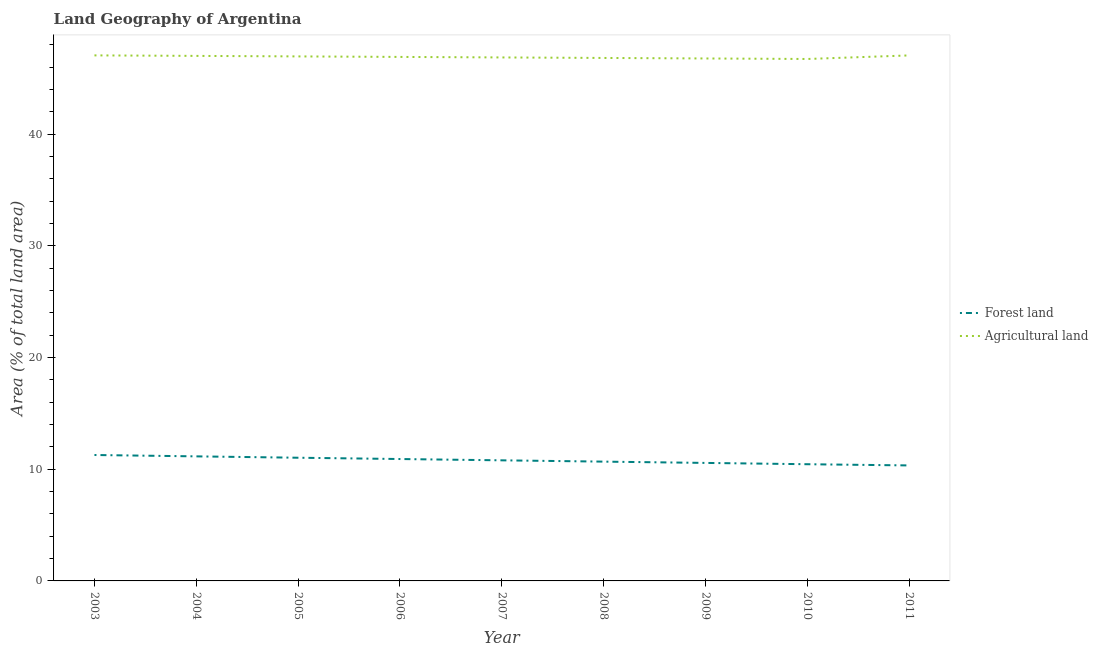Does the line corresponding to percentage of land area under forests intersect with the line corresponding to percentage of land area under agriculture?
Provide a short and direct response. No. Is the number of lines equal to the number of legend labels?
Offer a terse response. Yes. What is the percentage of land area under forests in 2004?
Ensure brevity in your answer.  11.15. Across all years, what is the maximum percentage of land area under agriculture?
Offer a terse response. 47.06. Across all years, what is the minimum percentage of land area under agriculture?
Ensure brevity in your answer.  46.73. What is the total percentage of land area under agriculture in the graph?
Make the answer very short. 422.21. What is the difference between the percentage of land area under forests in 2003 and that in 2010?
Your answer should be compact. 0.83. What is the difference between the percentage of land area under forests in 2008 and the percentage of land area under agriculture in 2010?
Make the answer very short. -36.05. What is the average percentage of land area under agriculture per year?
Provide a short and direct response. 46.91. In the year 2007, what is the difference between the percentage of land area under agriculture and percentage of land area under forests?
Ensure brevity in your answer.  36.07. What is the ratio of the percentage of land area under forests in 2004 to that in 2009?
Offer a terse response. 1.06. Is the percentage of land area under forests in 2006 less than that in 2011?
Ensure brevity in your answer.  No. What is the difference between the highest and the second highest percentage of land area under forests?
Offer a terse response. 0.12. What is the difference between the highest and the lowest percentage of land area under agriculture?
Give a very brief answer. 0.32. In how many years, is the percentage of land area under forests greater than the average percentage of land area under forests taken over all years?
Provide a short and direct response. 4. Is the percentage of land area under forests strictly greater than the percentage of land area under agriculture over the years?
Your answer should be very brief. No. Does the graph contain grids?
Make the answer very short. No. How many legend labels are there?
Provide a succinct answer. 2. What is the title of the graph?
Your response must be concise. Land Geography of Argentina. What is the label or title of the X-axis?
Provide a succinct answer. Year. What is the label or title of the Y-axis?
Give a very brief answer. Area (% of total land area). What is the Area (% of total land area) in Forest land in 2003?
Give a very brief answer. 11.27. What is the Area (% of total land area) of Agricultural land in 2003?
Offer a very short reply. 47.06. What is the Area (% of total land area) of Forest land in 2004?
Give a very brief answer. 11.15. What is the Area (% of total land area) of Agricultural land in 2004?
Offer a terse response. 47.01. What is the Area (% of total land area) of Forest land in 2005?
Give a very brief answer. 11.03. What is the Area (% of total land area) of Agricultural land in 2005?
Ensure brevity in your answer.  46.96. What is the Area (% of total land area) in Forest land in 2006?
Ensure brevity in your answer.  10.91. What is the Area (% of total land area) in Agricultural land in 2006?
Your response must be concise. 46.92. What is the Area (% of total land area) in Forest land in 2007?
Keep it short and to the point. 10.8. What is the Area (% of total land area) of Agricultural land in 2007?
Your answer should be compact. 46.87. What is the Area (% of total land area) in Forest land in 2008?
Provide a short and direct response. 10.68. What is the Area (% of total land area) of Agricultural land in 2008?
Provide a short and direct response. 46.83. What is the Area (% of total land area) of Forest land in 2009?
Keep it short and to the point. 10.57. What is the Area (% of total land area) of Agricultural land in 2009?
Keep it short and to the point. 46.78. What is the Area (% of total land area) in Forest land in 2010?
Offer a terse response. 10.45. What is the Area (% of total land area) of Agricultural land in 2010?
Make the answer very short. 46.73. What is the Area (% of total land area) in Forest land in 2011?
Your answer should be very brief. 10.34. What is the Area (% of total land area) of Agricultural land in 2011?
Keep it short and to the point. 47.05. Across all years, what is the maximum Area (% of total land area) of Forest land?
Ensure brevity in your answer.  11.27. Across all years, what is the maximum Area (% of total land area) in Agricultural land?
Offer a terse response. 47.06. Across all years, what is the minimum Area (% of total land area) in Forest land?
Provide a succinct answer. 10.34. Across all years, what is the minimum Area (% of total land area) in Agricultural land?
Your answer should be compact. 46.73. What is the total Area (% of total land area) in Forest land in the graph?
Your response must be concise. 97.21. What is the total Area (% of total land area) in Agricultural land in the graph?
Provide a short and direct response. 422.21. What is the difference between the Area (% of total land area) in Forest land in 2003 and that in 2004?
Give a very brief answer. 0.12. What is the difference between the Area (% of total land area) in Agricultural land in 2003 and that in 2004?
Provide a short and direct response. 0.05. What is the difference between the Area (% of total land area) in Forest land in 2003 and that in 2005?
Your answer should be very brief. 0.24. What is the difference between the Area (% of total land area) of Agricultural land in 2003 and that in 2005?
Keep it short and to the point. 0.09. What is the difference between the Area (% of total land area) in Forest land in 2003 and that in 2006?
Ensure brevity in your answer.  0.36. What is the difference between the Area (% of total land area) in Agricultural land in 2003 and that in 2006?
Make the answer very short. 0.14. What is the difference between the Area (% of total land area) in Forest land in 2003 and that in 2007?
Offer a terse response. 0.48. What is the difference between the Area (% of total land area) in Agricultural land in 2003 and that in 2007?
Your response must be concise. 0.18. What is the difference between the Area (% of total land area) of Forest land in 2003 and that in 2008?
Make the answer very short. 0.59. What is the difference between the Area (% of total land area) in Agricultural land in 2003 and that in 2008?
Ensure brevity in your answer.  0.23. What is the difference between the Area (% of total land area) of Forest land in 2003 and that in 2009?
Ensure brevity in your answer.  0.71. What is the difference between the Area (% of total land area) of Agricultural land in 2003 and that in 2009?
Make the answer very short. 0.28. What is the difference between the Area (% of total land area) of Forest land in 2003 and that in 2010?
Provide a short and direct response. 0.83. What is the difference between the Area (% of total land area) of Agricultural land in 2003 and that in 2010?
Your answer should be compact. 0.32. What is the difference between the Area (% of total land area) in Forest land in 2003 and that in 2011?
Keep it short and to the point. 0.93. What is the difference between the Area (% of total land area) of Agricultural land in 2003 and that in 2011?
Your answer should be compact. 0. What is the difference between the Area (% of total land area) in Forest land in 2004 and that in 2005?
Offer a very short reply. 0.12. What is the difference between the Area (% of total land area) in Agricultural land in 2004 and that in 2005?
Provide a short and direct response. 0.05. What is the difference between the Area (% of total land area) in Forest land in 2004 and that in 2006?
Ensure brevity in your answer.  0.24. What is the difference between the Area (% of total land area) in Agricultural land in 2004 and that in 2006?
Give a very brief answer. 0.09. What is the difference between the Area (% of total land area) in Forest land in 2004 and that in 2007?
Provide a succinct answer. 0.35. What is the difference between the Area (% of total land area) in Agricultural land in 2004 and that in 2007?
Provide a succinct answer. 0.14. What is the difference between the Area (% of total land area) in Forest land in 2004 and that in 2008?
Your response must be concise. 0.47. What is the difference between the Area (% of total land area) in Agricultural land in 2004 and that in 2008?
Your answer should be very brief. 0.18. What is the difference between the Area (% of total land area) of Forest land in 2004 and that in 2009?
Make the answer very short. 0.59. What is the difference between the Area (% of total land area) of Agricultural land in 2004 and that in 2009?
Your answer should be very brief. 0.23. What is the difference between the Area (% of total land area) in Forest land in 2004 and that in 2010?
Provide a short and direct response. 0.7. What is the difference between the Area (% of total land area) of Agricultural land in 2004 and that in 2010?
Ensure brevity in your answer.  0.28. What is the difference between the Area (% of total land area) of Forest land in 2004 and that in 2011?
Offer a very short reply. 0.81. What is the difference between the Area (% of total land area) of Agricultural land in 2004 and that in 2011?
Give a very brief answer. -0.04. What is the difference between the Area (% of total land area) in Forest land in 2005 and that in 2006?
Offer a terse response. 0.12. What is the difference between the Area (% of total land area) of Agricultural land in 2005 and that in 2006?
Provide a short and direct response. 0.05. What is the difference between the Area (% of total land area) of Forest land in 2005 and that in 2007?
Make the answer very short. 0.23. What is the difference between the Area (% of total land area) in Agricultural land in 2005 and that in 2007?
Offer a very short reply. 0.09. What is the difference between the Area (% of total land area) of Forest land in 2005 and that in 2008?
Your answer should be compact. 0.35. What is the difference between the Area (% of total land area) in Agricultural land in 2005 and that in 2008?
Give a very brief answer. 0.14. What is the difference between the Area (% of total land area) in Forest land in 2005 and that in 2009?
Ensure brevity in your answer.  0.46. What is the difference between the Area (% of total land area) of Agricultural land in 2005 and that in 2009?
Offer a very short reply. 0.18. What is the difference between the Area (% of total land area) of Forest land in 2005 and that in 2010?
Your answer should be compact. 0.58. What is the difference between the Area (% of total land area) in Agricultural land in 2005 and that in 2010?
Give a very brief answer. 0.23. What is the difference between the Area (% of total land area) in Forest land in 2005 and that in 2011?
Provide a short and direct response. 0.69. What is the difference between the Area (% of total land area) in Agricultural land in 2005 and that in 2011?
Keep it short and to the point. -0.09. What is the difference between the Area (% of total land area) in Forest land in 2006 and that in 2007?
Keep it short and to the point. 0.12. What is the difference between the Area (% of total land area) of Agricultural land in 2006 and that in 2007?
Your response must be concise. 0.05. What is the difference between the Area (% of total land area) of Forest land in 2006 and that in 2008?
Give a very brief answer. 0.23. What is the difference between the Area (% of total land area) of Agricultural land in 2006 and that in 2008?
Give a very brief answer. 0.09. What is the difference between the Area (% of total land area) in Forest land in 2006 and that in 2009?
Your response must be concise. 0.35. What is the difference between the Area (% of total land area) of Agricultural land in 2006 and that in 2009?
Offer a terse response. 0.14. What is the difference between the Area (% of total land area) in Forest land in 2006 and that in 2010?
Provide a succinct answer. 0.46. What is the difference between the Area (% of total land area) in Agricultural land in 2006 and that in 2010?
Make the answer very short. 0.18. What is the difference between the Area (% of total land area) in Forest land in 2006 and that in 2011?
Your response must be concise. 0.57. What is the difference between the Area (% of total land area) in Agricultural land in 2006 and that in 2011?
Offer a terse response. -0.14. What is the difference between the Area (% of total land area) in Forest land in 2007 and that in 2008?
Your response must be concise. 0.12. What is the difference between the Area (% of total land area) in Agricultural land in 2007 and that in 2008?
Give a very brief answer. 0.05. What is the difference between the Area (% of total land area) of Forest land in 2007 and that in 2009?
Provide a short and direct response. 0.23. What is the difference between the Area (% of total land area) in Agricultural land in 2007 and that in 2009?
Keep it short and to the point. 0.09. What is the difference between the Area (% of total land area) in Forest land in 2007 and that in 2010?
Make the answer very short. 0.35. What is the difference between the Area (% of total land area) of Agricultural land in 2007 and that in 2010?
Provide a short and direct response. 0.14. What is the difference between the Area (% of total land area) of Forest land in 2007 and that in 2011?
Your response must be concise. 0.46. What is the difference between the Area (% of total land area) in Agricultural land in 2007 and that in 2011?
Provide a succinct answer. -0.18. What is the difference between the Area (% of total land area) in Forest land in 2008 and that in 2009?
Give a very brief answer. 0.12. What is the difference between the Area (% of total land area) of Agricultural land in 2008 and that in 2009?
Offer a very short reply. 0.05. What is the difference between the Area (% of total land area) of Forest land in 2008 and that in 2010?
Provide a succinct answer. 0.23. What is the difference between the Area (% of total land area) in Agricultural land in 2008 and that in 2010?
Keep it short and to the point. 0.09. What is the difference between the Area (% of total land area) in Forest land in 2008 and that in 2011?
Give a very brief answer. 0.34. What is the difference between the Area (% of total land area) in Agricultural land in 2008 and that in 2011?
Give a very brief answer. -0.23. What is the difference between the Area (% of total land area) in Forest land in 2009 and that in 2010?
Offer a very short reply. 0.12. What is the difference between the Area (% of total land area) in Agricultural land in 2009 and that in 2010?
Give a very brief answer. 0.05. What is the difference between the Area (% of total land area) in Forest land in 2009 and that in 2011?
Ensure brevity in your answer.  0.22. What is the difference between the Area (% of total land area) in Agricultural land in 2009 and that in 2011?
Offer a terse response. -0.27. What is the difference between the Area (% of total land area) in Forest land in 2010 and that in 2011?
Offer a terse response. 0.11. What is the difference between the Area (% of total land area) in Agricultural land in 2010 and that in 2011?
Provide a short and direct response. -0.32. What is the difference between the Area (% of total land area) in Forest land in 2003 and the Area (% of total land area) in Agricultural land in 2004?
Your response must be concise. -35.73. What is the difference between the Area (% of total land area) in Forest land in 2003 and the Area (% of total land area) in Agricultural land in 2005?
Your response must be concise. -35.69. What is the difference between the Area (% of total land area) of Forest land in 2003 and the Area (% of total land area) of Agricultural land in 2006?
Keep it short and to the point. -35.64. What is the difference between the Area (% of total land area) of Forest land in 2003 and the Area (% of total land area) of Agricultural land in 2007?
Make the answer very short. -35.6. What is the difference between the Area (% of total land area) in Forest land in 2003 and the Area (% of total land area) in Agricultural land in 2008?
Offer a very short reply. -35.55. What is the difference between the Area (% of total land area) of Forest land in 2003 and the Area (% of total land area) of Agricultural land in 2009?
Give a very brief answer. -35.5. What is the difference between the Area (% of total land area) of Forest land in 2003 and the Area (% of total land area) of Agricultural land in 2010?
Your answer should be compact. -35.46. What is the difference between the Area (% of total land area) in Forest land in 2003 and the Area (% of total land area) in Agricultural land in 2011?
Your answer should be very brief. -35.78. What is the difference between the Area (% of total land area) in Forest land in 2004 and the Area (% of total land area) in Agricultural land in 2005?
Make the answer very short. -35.81. What is the difference between the Area (% of total land area) of Forest land in 2004 and the Area (% of total land area) of Agricultural land in 2006?
Your answer should be very brief. -35.76. What is the difference between the Area (% of total land area) in Forest land in 2004 and the Area (% of total land area) in Agricultural land in 2007?
Provide a succinct answer. -35.72. What is the difference between the Area (% of total land area) in Forest land in 2004 and the Area (% of total land area) in Agricultural land in 2008?
Give a very brief answer. -35.67. What is the difference between the Area (% of total land area) of Forest land in 2004 and the Area (% of total land area) of Agricultural land in 2009?
Provide a succinct answer. -35.63. What is the difference between the Area (% of total land area) in Forest land in 2004 and the Area (% of total land area) in Agricultural land in 2010?
Give a very brief answer. -35.58. What is the difference between the Area (% of total land area) of Forest land in 2004 and the Area (% of total land area) of Agricultural land in 2011?
Make the answer very short. -35.9. What is the difference between the Area (% of total land area) of Forest land in 2005 and the Area (% of total land area) of Agricultural land in 2006?
Your answer should be compact. -35.89. What is the difference between the Area (% of total land area) of Forest land in 2005 and the Area (% of total land area) of Agricultural land in 2007?
Give a very brief answer. -35.84. What is the difference between the Area (% of total land area) of Forest land in 2005 and the Area (% of total land area) of Agricultural land in 2008?
Give a very brief answer. -35.8. What is the difference between the Area (% of total land area) in Forest land in 2005 and the Area (% of total land area) in Agricultural land in 2009?
Your response must be concise. -35.75. What is the difference between the Area (% of total land area) in Forest land in 2005 and the Area (% of total land area) in Agricultural land in 2010?
Your answer should be very brief. -35.7. What is the difference between the Area (% of total land area) in Forest land in 2005 and the Area (% of total land area) in Agricultural land in 2011?
Give a very brief answer. -36.02. What is the difference between the Area (% of total land area) in Forest land in 2006 and the Area (% of total land area) in Agricultural land in 2007?
Ensure brevity in your answer.  -35.96. What is the difference between the Area (% of total land area) of Forest land in 2006 and the Area (% of total land area) of Agricultural land in 2008?
Your answer should be compact. -35.91. What is the difference between the Area (% of total land area) of Forest land in 2006 and the Area (% of total land area) of Agricultural land in 2009?
Ensure brevity in your answer.  -35.87. What is the difference between the Area (% of total land area) in Forest land in 2006 and the Area (% of total land area) in Agricultural land in 2010?
Provide a succinct answer. -35.82. What is the difference between the Area (% of total land area) of Forest land in 2006 and the Area (% of total land area) of Agricultural land in 2011?
Give a very brief answer. -36.14. What is the difference between the Area (% of total land area) of Forest land in 2007 and the Area (% of total land area) of Agricultural land in 2008?
Give a very brief answer. -36.03. What is the difference between the Area (% of total land area) of Forest land in 2007 and the Area (% of total land area) of Agricultural land in 2009?
Provide a short and direct response. -35.98. What is the difference between the Area (% of total land area) in Forest land in 2007 and the Area (% of total land area) in Agricultural land in 2010?
Provide a short and direct response. -35.94. What is the difference between the Area (% of total land area) of Forest land in 2007 and the Area (% of total land area) of Agricultural land in 2011?
Provide a succinct answer. -36.26. What is the difference between the Area (% of total land area) in Forest land in 2008 and the Area (% of total land area) in Agricultural land in 2009?
Your answer should be very brief. -36.1. What is the difference between the Area (% of total land area) of Forest land in 2008 and the Area (% of total land area) of Agricultural land in 2010?
Provide a succinct answer. -36.05. What is the difference between the Area (% of total land area) of Forest land in 2008 and the Area (% of total land area) of Agricultural land in 2011?
Offer a terse response. -36.37. What is the difference between the Area (% of total land area) of Forest land in 2009 and the Area (% of total land area) of Agricultural land in 2010?
Ensure brevity in your answer.  -36.17. What is the difference between the Area (% of total land area) of Forest land in 2009 and the Area (% of total land area) of Agricultural land in 2011?
Offer a very short reply. -36.49. What is the difference between the Area (% of total land area) in Forest land in 2010 and the Area (% of total land area) in Agricultural land in 2011?
Keep it short and to the point. -36.6. What is the average Area (% of total land area) in Forest land per year?
Your answer should be compact. 10.8. What is the average Area (% of total land area) in Agricultural land per year?
Your response must be concise. 46.91. In the year 2003, what is the difference between the Area (% of total land area) in Forest land and Area (% of total land area) in Agricultural land?
Offer a very short reply. -35.78. In the year 2004, what is the difference between the Area (% of total land area) of Forest land and Area (% of total land area) of Agricultural land?
Provide a short and direct response. -35.86. In the year 2005, what is the difference between the Area (% of total land area) of Forest land and Area (% of total land area) of Agricultural land?
Keep it short and to the point. -35.93. In the year 2006, what is the difference between the Area (% of total land area) in Forest land and Area (% of total land area) in Agricultural land?
Provide a short and direct response. -36. In the year 2007, what is the difference between the Area (% of total land area) of Forest land and Area (% of total land area) of Agricultural land?
Your answer should be very brief. -36.07. In the year 2008, what is the difference between the Area (% of total land area) in Forest land and Area (% of total land area) in Agricultural land?
Your answer should be very brief. -36.14. In the year 2009, what is the difference between the Area (% of total land area) in Forest land and Area (% of total land area) in Agricultural land?
Provide a succinct answer. -36.21. In the year 2010, what is the difference between the Area (% of total land area) of Forest land and Area (% of total land area) of Agricultural land?
Your answer should be compact. -36.28. In the year 2011, what is the difference between the Area (% of total land area) in Forest land and Area (% of total land area) in Agricultural land?
Give a very brief answer. -36.71. What is the ratio of the Area (% of total land area) of Forest land in 2003 to that in 2005?
Provide a short and direct response. 1.02. What is the ratio of the Area (% of total land area) in Forest land in 2003 to that in 2006?
Your answer should be compact. 1.03. What is the ratio of the Area (% of total land area) of Agricultural land in 2003 to that in 2006?
Ensure brevity in your answer.  1. What is the ratio of the Area (% of total land area) of Forest land in 2003 to that in 2007?
Keep it short and to the point. 1.04. What is the ratio of the Area (% of total land area) in Agricultural land in 2003 to that in 2007?
Offer a terse response. 1. What is the ratio of the Area (% of total land area) of Forest land in 2003 to that in 2008?
Your answer should be compact. 1.06. What is the ratio of the Area (% of total land area) in Agricultural land in 2003 to that in 2008?
Your response must be concise. 1. What is the ratio of the Area (% of total land area) of Forest land in 2003 to that in 2009?
Ensure brevity in your answer.  1.07. What is the ratio of the Area (% of total land area) in Agricultural land in 2003 to that in 2009?
Your answer should be very brief. 1.01. What is the ratio of the Area (% of total land area) of Forest land in 2003 to that in 2010?
Provide a short and direct response. 1.08. What is the ratio of the Area (% of total land area) in Forest land in 2003 to that in 2011?
Offer a terse response. 1.09. What is the ratio of the Area (% of total land area) in Agricultural land in 2003 to that in 2011?
Give a very brief answer. 1. What is the ratio of the Area (% of total land area) of Forest land in 2004 to that in 2005?
Provide a succinct answer. 1.01. What is the ratio of the Area (% of total land area) in Agricultural land in 2004 to that in 2005?
Your response must be concise. 1. What is the ratio of the Area (% of total land area) of Forest land in 2004 to that in 2006?
Make the answer very short. 1.02. What is the ratio of the Area (% of total land area) in Forest land in 2004 to that in 2007?
Give a very brief answer. 1.03. What is the ratio of the Area (% of total land area) in Forest land in 2004 to that in 2008?
Give a very brief answer. 1.04. What is the ratio of the Area (% of total land area) of Agricultural land in 2004 to that in 2008?
Provide a succinct answer. 1. What is the ratio of the Area (% of total land area) in Forest land in 2004 to that in 2009?
Offer a very short reply. 1.06. What is the ratio of the Area (% of total land area) in Forest land in 2004 to that in 2010?
Offer a terse response. 1.07. What is the ratio of the Area (% of total land area) in Agricultural land in 2004 to that in 2010?
Ensure brevity in your answer.  1.01. What is the ratio of the Area (% of total land area) in Forest land in 2004 to that in 2011?
Offer a very short reply. 1.08. What is the ratio of the Area (% of total land area) in Forest land in 2005 to that in 2006?
Keep it short and to the point. 1.01. What is the ratio of the Area (% of total land area) of Forest land in 2005 to that in 2007?
Keep it short and to the point. 1.02. What is the ratio of the Area (% of total land area) of Forest land in 2005 to that in 2008?
Give a very brief answer. 1.03. What is the ratio of the Area (% of total land area) in Forest land in 2005 to that in 2009?
Offer a terse response. 1.04. What is the ratio of the Area (% of total land area) of Agricultural land in 2005 to that in 2009?
Your response must be concise. 1. What is the ratio of the Area (% of total land area) of Forest land in 2005 to that in 2010?
Ensure brevity in your answer.  1.06. What is the ratio of the Area (% of total land area) of Forest land in 2005 to that in 2011?
Provide a short and direct response. 1.07. What is the ratio of the Area (% of total land area) in Forest land in 2006 to that in 2007?
Your answer should be compact. 1.01. What is the ratio of the Area (% of total land area) of Agricultural land in 2006 to that in 2007?
Give a very brief answer. 1. What is the ratio of the Area (% of total land area) of Forest land in 2006 to that in 2008?
Offer a terse response. 1.02. What is the ratio of the Area (% of total land area) in Forest land in 2006 to that in 2009?
Provide a succinct answer. 1.03. What is the ratio of the Area (% of total land area) of Forest land in 2006 to that in 2010?
Keep it short and to the point. 1.04. What is the ratio of the Area (% of total land area) of Agricultural land in 2006 to that in 2010?
Your response must be concise. 1. What is the ratio of the Area (% of total land area) in Forest land in 2006 to that in 2011?
Give a very brief answer. 1.06. What is the ratio of the Area (% of total land area) of Forest land in 2007 to that in 2008?
Provide a succinct answer. 1.01. What is the ratio of the Area (% of total land area) of Agricultural land in 2007 to that in 2009?
Your answer should be very brief. 1. What is the ratio of the Area (% of total land area) in Forest land in 2007 to that in 2010?
Provide a short and direct response. 1.03. What is the ratio of the Area (% of total land area) in Agricultural land in 2007 to that in 2010?
Provide a succinct answer. 1. What is the ratio of the Area (% of total land area) of Forest land in 2007 to that in 2011?
Your answer should be very brief. 1.04. What is the ratio of the Area (% of total land area) in Agricultural land in 2007 to that in 2011?
Your answer should be very brief. 1. What is the ratio of the Area (% of total land area) in Forest land in 2008 to that in 2009?
Keep it short and to the point. 1.01. What is the ratio of the Area (% of total land area) of Forest land in 2008 to that in 2010?
Make the answer very short. 1.02. What is the ratio of the Area (% of total land area) in Forest land in 2008 to that in 2011?
Your answer should be very brief. 1.03. What is the ratio of the Area (% of total land area) in Agricultural land in 2008 to that in 2011?
Make the answer very short. 1. What is the ratio of the Area (% of total land area) of Forest land in 2009 to that in 2010?
Provide a succinct answer. 1.01. What is the ratio of the Area (% of total land area) in Agricultural land in 2009 to that in 2010?
Provide a short and direct response. 1. What is the ratio of the Area (% of total land area) of Forest land in 2009 to that in 2011?
Your response must be concise. 1.02. What is the ratio of the Area (% of total land area) in Forest land in 2010 to that in 2011?
Provide a succinct answer. 1.01. What is the difference between the highest and the second highest Area (% of total land area) of Forest land?
Provide a succinct answer. 0.12. What is the difference between the highest and the second highest Area (% of total land area) of Agricultural land?
Offer a very short reply. 0. What is the difference between the highest and the lowest Area (% of total land area) in Forest land?
Provide a short and direct response. 0.93. What is the difference between the highest and the lowest Area (% of total land area) of Agricultural land?
Offer a terse response. 0.32. 